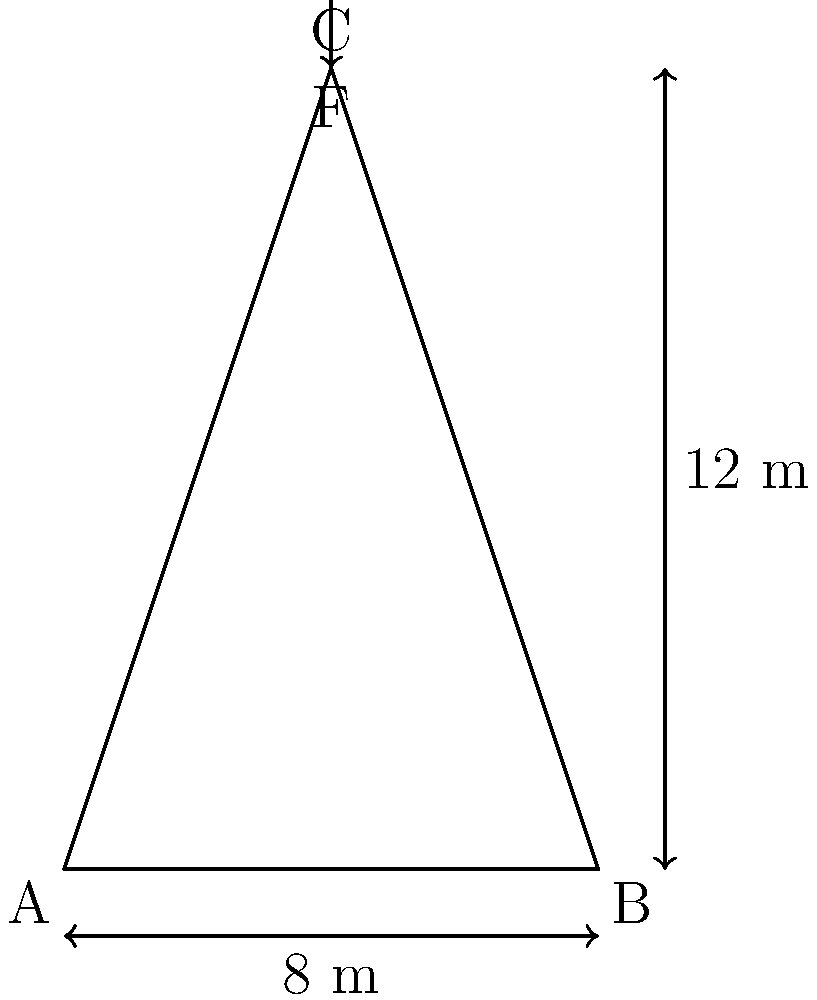As an architect specializing in religious architecture, you are tasked with calculating the load-bearing capacity of a church spire. The spire is triangular in shape with a base width of 8 meters and a height of 12 meters. A force $F$ is applied vertically at the apex of the spire. If the maximum compressive stress that the masonry can withstand is 5 MPa, and the cross-sectional area at the base is 2 m², what is the maximum force $F$ that can be safely applied to the spire? To solve this problem, we'll follow these steps:

1) First, we need to understand that the compressive stress at the base of the spire will determine its load-bearing capacity.

2) The compressive stress is given by the formula:
   $$\sigma = \frac{F}{A}$$
   where $\sigma$ is the stress, $F$ is the force, and $A$ is the area.

3) We are given that the maximum compressive stress ($\sigma_{max}$) is 5 MPa and the cross-sectional area at the base ($A$) is 2 m².

4) Rearranging the stress formula to solve for $F$:
   $$F = \sigma A$$

5) Substituting the known values:
   $$F = (5 \times 10^6 \text{ Pa})(2 \text{ m}^2)$$

6) Calculating:
   $$F = 10 \times 10^6 \text{ N} = 10 \text{ MN}$$

Therefore, the maximum force that can be safely applied to the spire is 10 MN.
Answer: 10 MN 